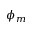<formula> <loc_0><loc_0><loc_500><loc_500>\phi _ { m }</formula> 